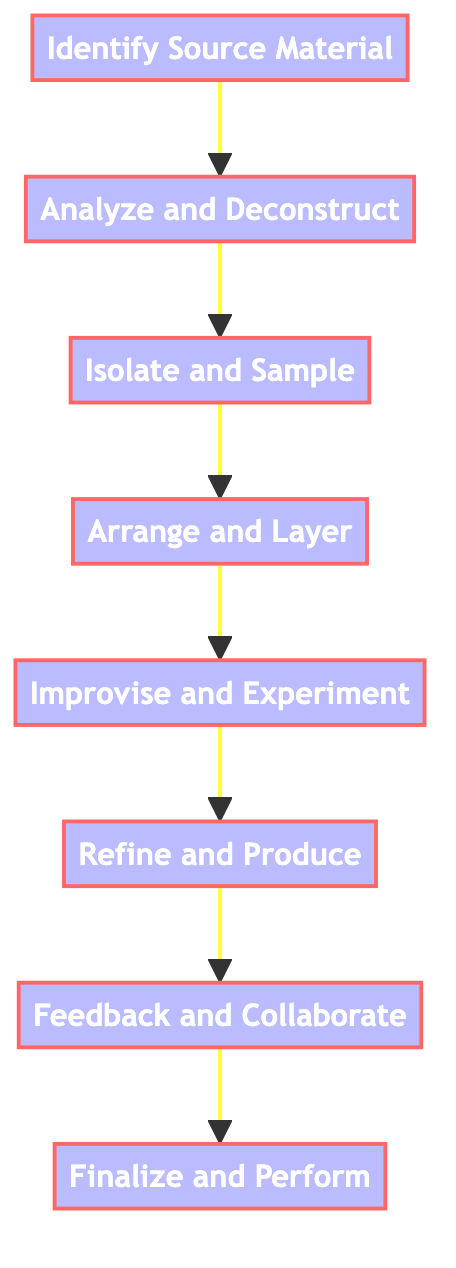What is the first step in the creative process? The flowchart indicates that the first step is "Identify Source Material." This can be seen at the starting node of the diagram, from which all other steps lead.
Answer: Identify Source Material How many steps are in the process? By counting the nodes in the flowchart, there are a total of eight steps that detail the creative process involved in sampling and improvisation.
Answer: Eight What follows after "Arrange and Layer"? The diagram shows that "Improvise and Experiment" directly follows "Arrange and Layer," indicating the next phase in the process.
Answer: Improvise and Experiment What is a key example for “Refine and Produce”? The flowchart mentions that producers like DJ Premier or Madlib emphasize this step, highlighting specific individuals known for their refinement techniques.
Answer: DJ Premier or Madlib What two steps are connected by a direct edge? Analyzing the flow of the diagram reveals several connections; one specific example is between "Identify Source Material" and "Analyze and Deconstruct."
Answer: Identify Source Material and Analyze and Deconstruct Which step is last in the creative process? The final node in the flowchart is "Finalize and Perform," which concludes the entire sampling and improvisation process.
Answer: Finalize and Perform Which step involves collaboration? The node that addresses collaboration is "Feedback and Collaborate," indicating that sharing work with others is crucial at this stage.
Answer: Feedback and Collaborate What action occurs directly before “Refine and Produce”? The diagram shows that "Improvise and Experiment" happens right before "Refine and Produce," suggesting a progression from creative play to fine-tuning.
Answer: Improvise and Experiment 